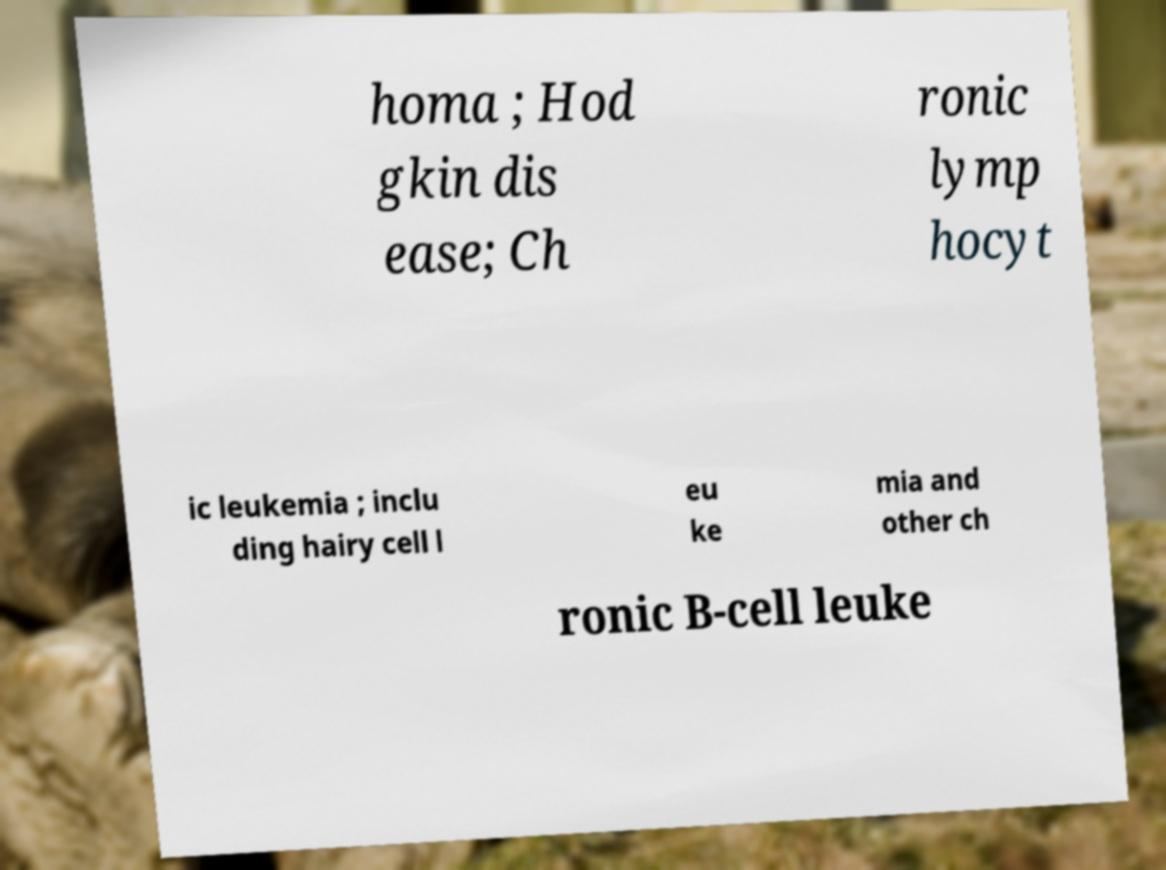Can you read and provide the text displayed in the image?This photo seems to have some interesting text. Can you extract and type it out for me? homa ; Hod gkin dis ease; Ch ronic lymp hocyt ic leukemia ; inclu ding hairy cell l eu ke mia and other ch ronic B-cell leuke 